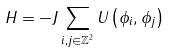<formula> <loc_0><loc_0><loc_500><loc_500>H = - J \sum _ { i , j \in \mathbb { Z } ^ { 2 } } U \left ( \phi _ { i } , \phi _ { j } \right )</formula> 